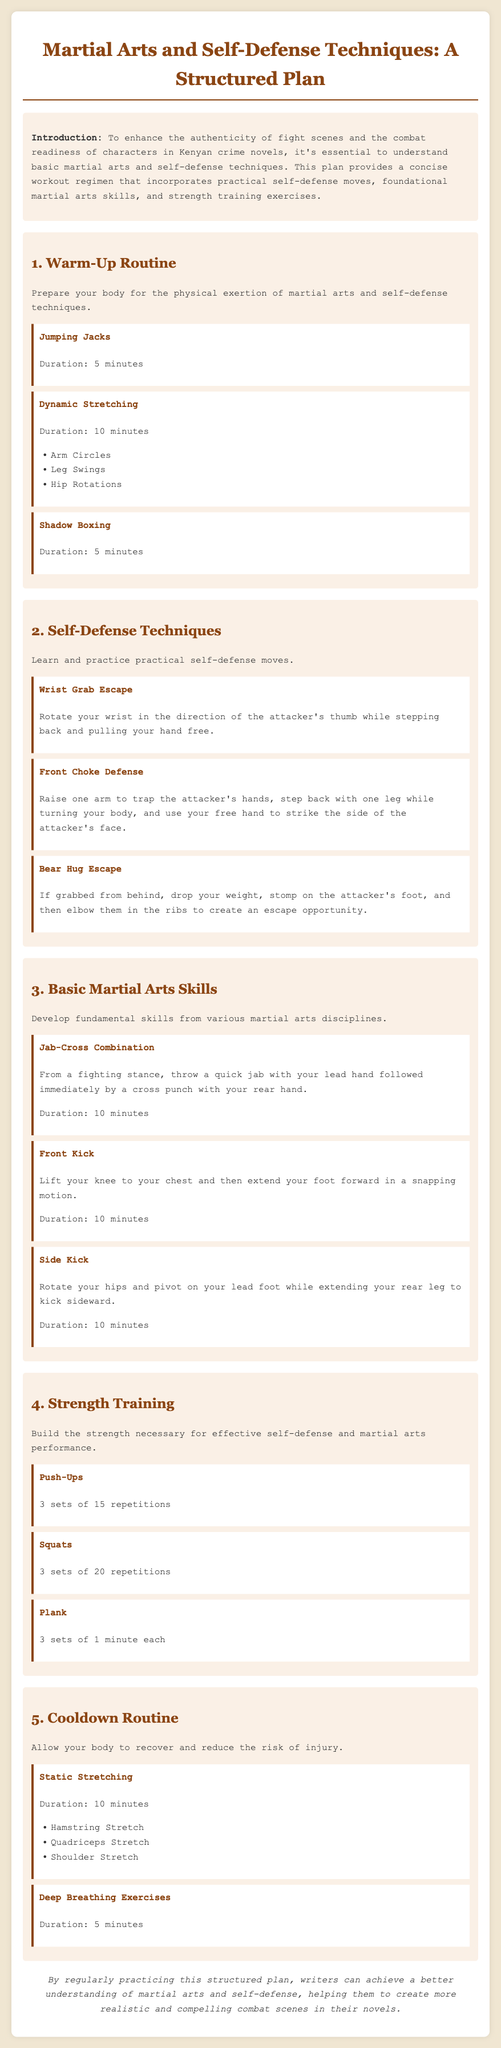What is the duration of Jumping Jacks? The duration for Jumping Jacks is specified in the document as 5 minutes.
Answer: 5 minutes What is the first self-defense technique mentioned? The document lists "Wrist Grab Escape" as the first self-defense technique.
Answer: Wrist Grab Escape How many repetitions are recommended for Push-Ups? The document states that 3 sets of 15 repetitions are recommended for Push-Ups.
Answer: 3 sets of 15 What are the three dynamic stretching exercises listed? The document includes Arm Circles, Leg Swings, and Hip Rotations as part of the dynamic stretching routine.
Answer: Arm Circles, Leg Swings, Hip Rotations What is the purpose of the cooldown routine? The cooldown routine aims to allow the body to recover and reduce the risk of injury.
Answer: Recovery and injury reduction How many minutes is the cooldown routine for static stretching? The document specifies that the duration for static stretching is 10 minutes.
Answer: 10 minutes What type of training exercises are emphasized in section 4? Section 4 focuses on strength training exercises necessary for effective self-defense and martial arts performance.
Answer: Strength training Which martial arts skill involves a quick jab? The "Jab-Cross Combination" involves a quick jab with the lead hand.
Answer: Jab-Cross Combination What is the concluding statement about the structured plan? The conclusion states that practicing the structured plan helps writers create more realistic combat scenes.
Answer: Helps create realistic combat scenes 